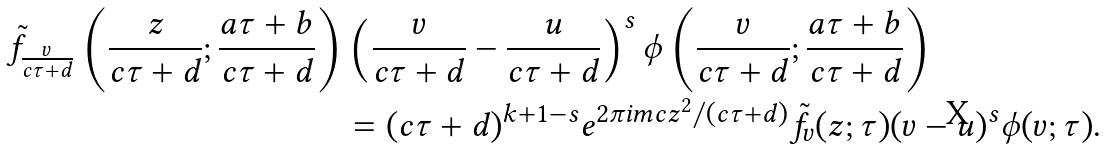<formula> <loc_0><loc_0><loc_500><loc_500>\tilde { f } _ { \frac { v } { c \tau + d } } \left ( \frac { z } { c \tau + d } ; \frac { a \tau + b } { c \tau + d } \right ) & \left ( \frac { v } { c \tau + d } - \frac { u } { c \tau + d } \right ) ^ { s } \phi \left ( \frac { v } { c \tau + d } ; \frac { a \tau + b } { c \tau + d } \right ) \\ & = ( c \tau + d ) ^ { k + 1 - s } e ^ { 2 \pi i m c z ^ { 2 } / ( c \tau + d ) } \tilde { f } _ { v } ( z ; \tau ) ( v - u ) ^ { s } \phi ( v ; \tau ) .</formula> 